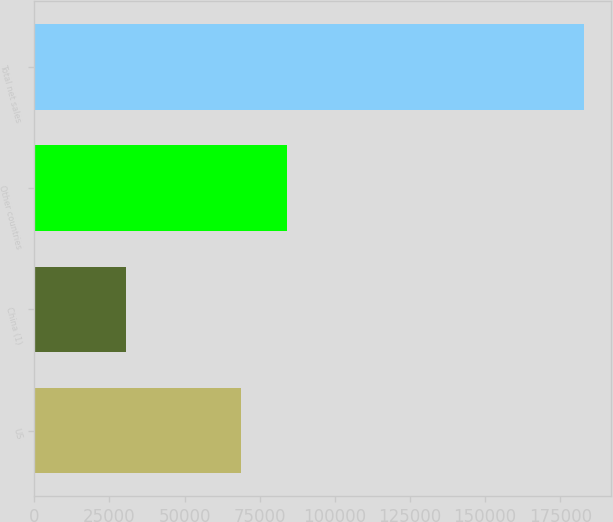<chart> <loc_0><loc_0><loc_500><loc_500><bar_chart><fcel>US<fcel>China (1)<fcel>Other countries<fcel>Total net sales<nl><fcel>68909<fcel>30638<fcel>84124.7<fcel>182795<nl></chart> 